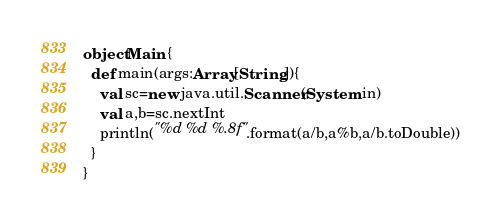<code> <loc_0><loc_0><loc_500><loc_500><_Scala_>object Main {
  def main(args:Array[String]){
    val sc=new java.util.Scanner(System.in)
    val a,b=sc.nextInt
    println("%d %d %.8f".format(a/b,a%b,a/b.toDouble))
  }
}

</code> 